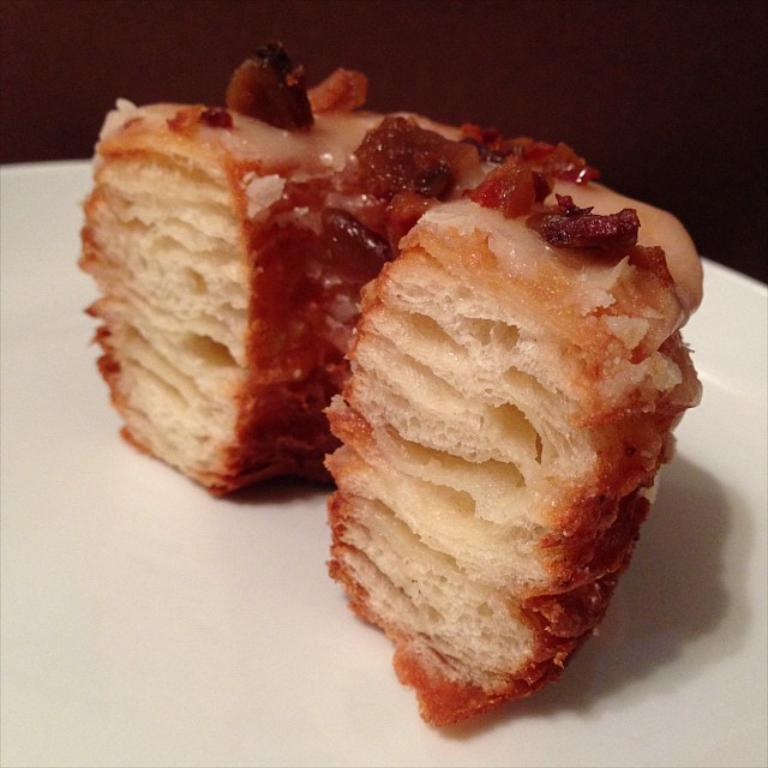What is on the plate in the image? There is a food item on the plate in the image. What type of amusement can be seen in the image? There is no amusement present in the image; it only contains a plate with a food item. In what year was the food item on the plate created? The provided facts do not include information about the year the food item was created, so it cannot be determined from the image. 